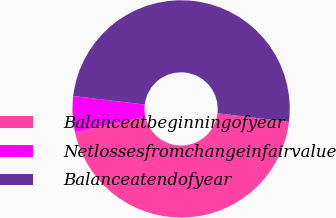<chart> <loc_0><loc_0><loc_500><loc_500><pie_chart><fcel>Balanceatbeginningofyear<fcel>Netlossesfromchangeinfairvalue<fcel>Balanceatendofyear<nl><fcel>44.68%<fcel>5.32%<fcel>50.0%<nl></chart> 